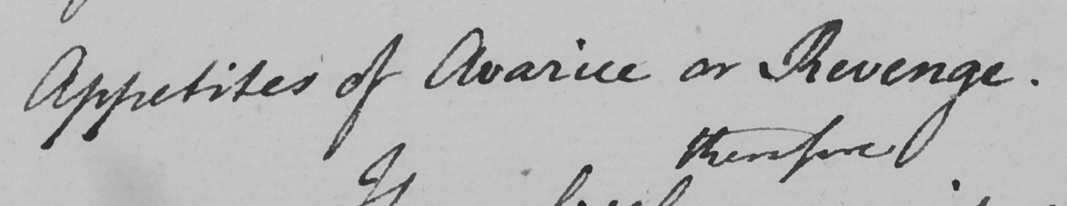Transcribe the text shown in this historical manuscript line. Appetites of Avarice or Revenge . 